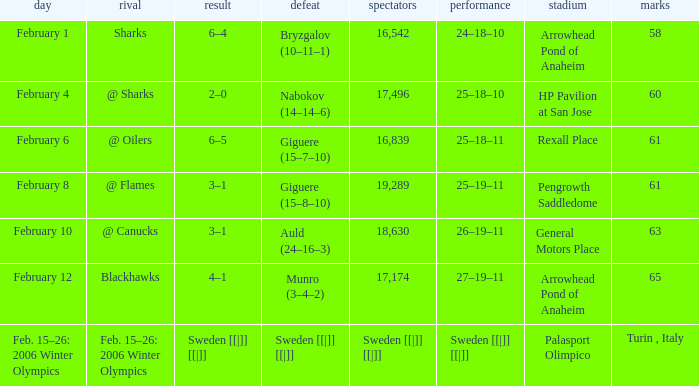What is the Arena when there were 65 points? Arrowhead Pond of Anaheim. 